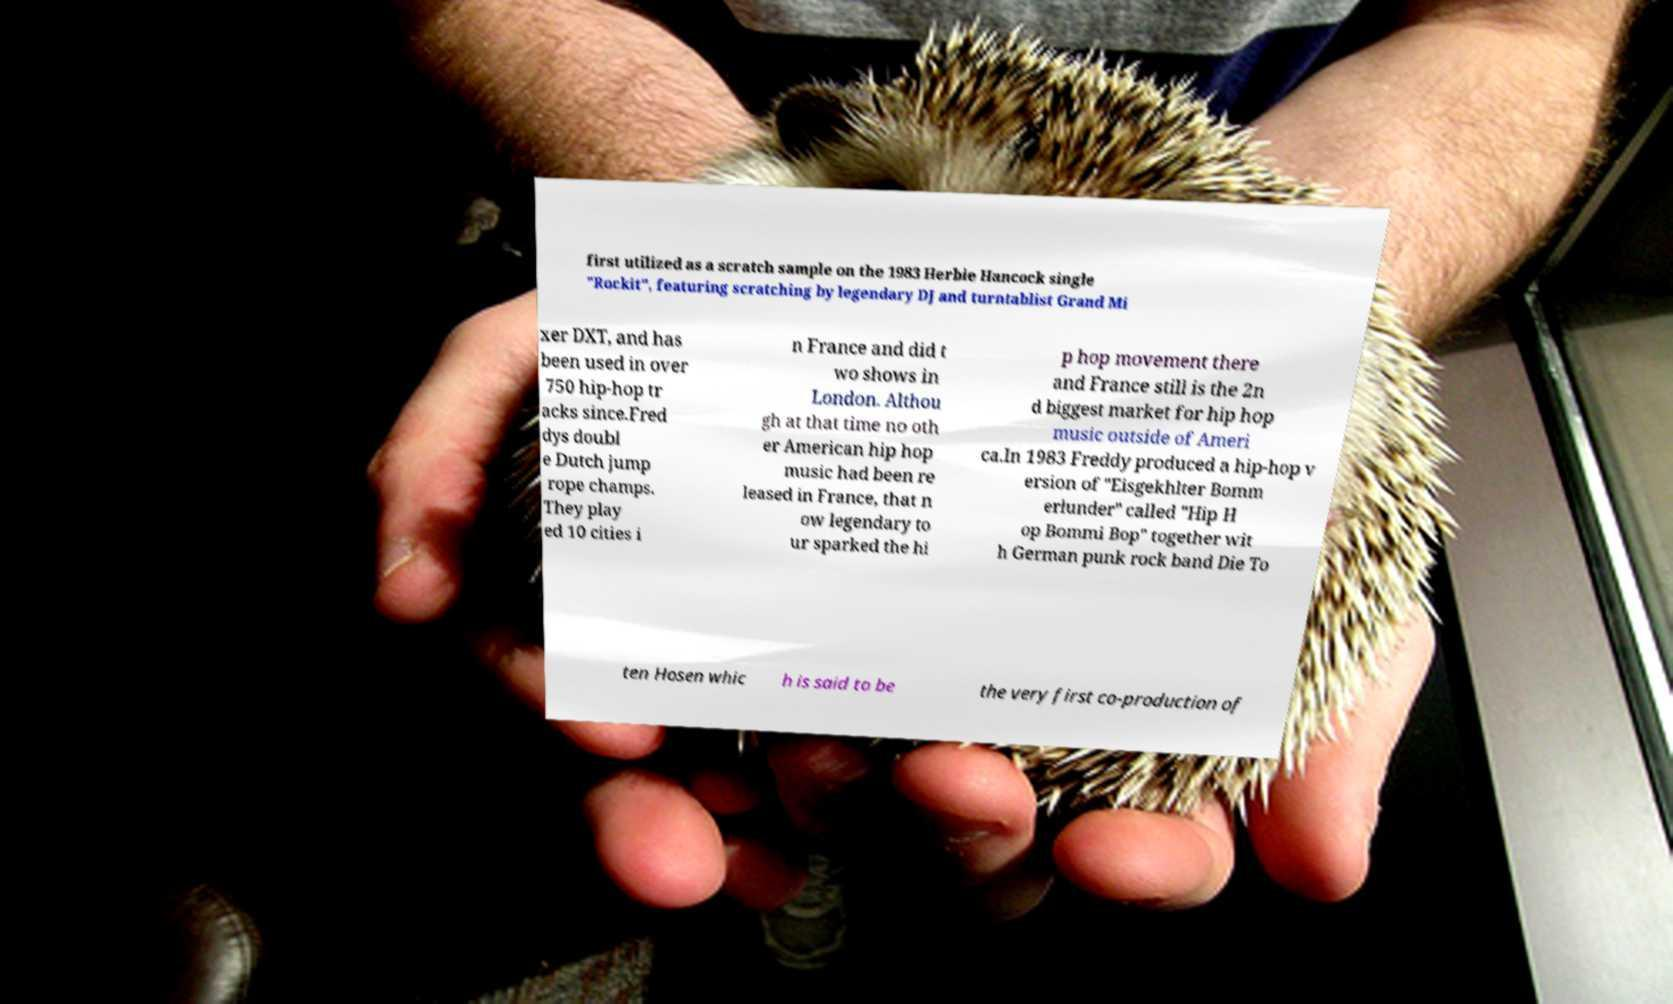Can you accurately transcribe the text from the provided image for me? first utilized as a scratch sample on the 1983 Herbie Hancock single "Rockit", featuring scratching by legendary DJ and turntablist Grand Mi xer DXT, and has been used in over 750 hip-hop tr acks since.Fred dys doubl e Dutch jump rope champs. They play ed 10 cities i n France and did t wo shows in London. Althou gh at that time no oth er American hip hop music had been re leased in France, that n ow legendary to ur sparked the hi p hop movement there and France still is the 2n d biggest market for hip hop music outside of Ameri ca.In 1983 Freddy produced a hip-hop v ersion of "Eisgekhlter Bomm erlunder" called "Hip H op Bommi Bop" together wit h German punk rock band Die To ten Hosen whic h is said to be the very first co-production of 